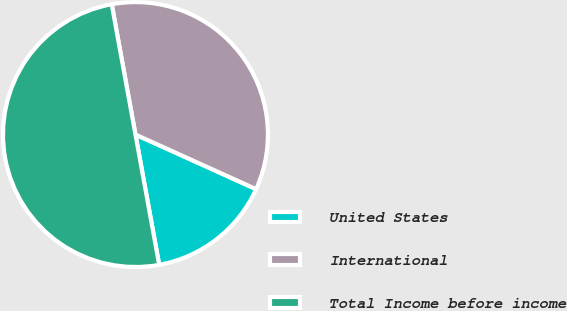<chart> <loc_0><loc_0><loc_500><loc_500><pie_chart><fcel>United States<fcel>International<fcel>Total Income before income<nl><fcel>15.37%<fcel>34.63%<fcel>50.0%<nl></chart> 